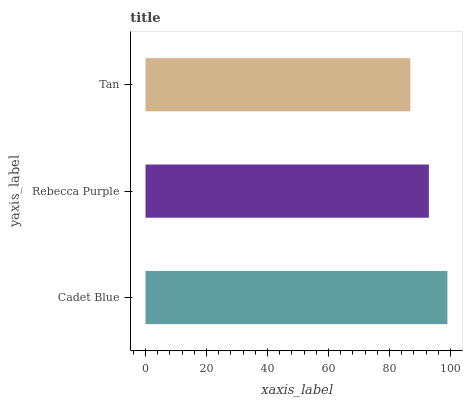Is Tan the minimum?
Answer yes or no. Yes. Is Cadet Blue the maximum?
Answer yes or no. Yes. Is Rebecca Purple the minimum?
Answer yes or no. No. Is Rebecca Purple the maximum?
Answer yes or no. No. Is Cadet Blue greater than Rebecca Purple?
Answer yes or no. Yes. Is Rebecca Purple less than Cadet Blue?
Answer yes or no. Yes. Is Rebecca Purple greater than Cadet Blue?
Answer yes or no. No. Is Cadet Blue less than Rebecca Purple?
Answer yes or no. No. Is Rebecca Purple the high median?
Answer yes or no. Yes. Is Rebecca Purple the low median?
Answer yes or no. Yes. Is Tan the high median?
Answer yes or no. No. Is Cadet Blue the low median?
Answer yes or no. No. 